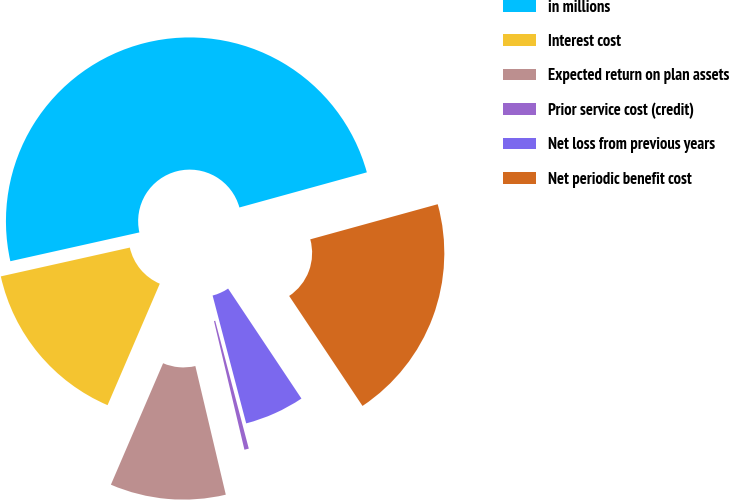Convert chart. <chart><loc_0><loc_0><loc_500><loc_500><pie_chart><fcel>in millions<fcel>Interest cost<fcel>Expected return on plan assets<fcel>Prior service cost (credit)<fcel>Net loss from previous years<fcel>Net periodic benefit cost<nl><fcel>49.21%<fcel>15.04%<fcel>10.16%<fcel>0.39%<fcel>5.27%<fcel>19.92%<nl></chart> 